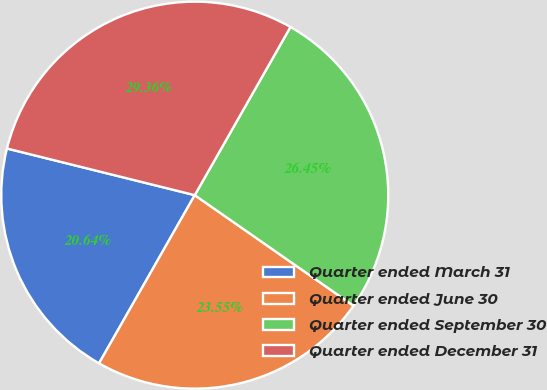Convert chart. <chart><loc_0><loc_0><loc_500><loc_500><pie_chart><fcel>Quarter ended March 31<fcel>Quarter ended June 30<fcel>Quarter ended September 30<fcel>Quarter ended December 31<nl><fcel>20.64%<fcel>23.55%<fcel>26.45%<fcel>29.36%<nl></chart> 